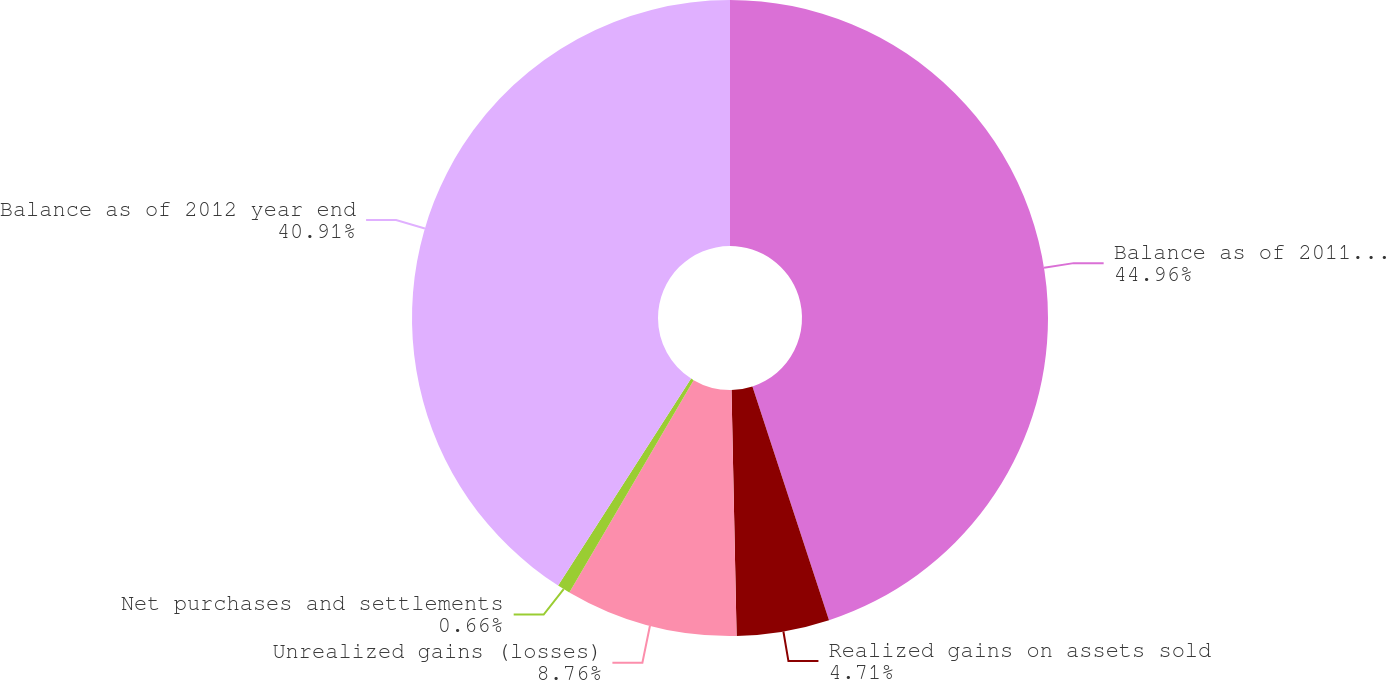Convert chart. <chart><loc_0><loc_0><loc_500><loc_500><pie_chart><fcel>Balance as of 2011 year end<fcel>Realized gains on assets sold<fcel>Unrealized gains (losses)<fcel>Net purchases and settlements<fcel>Balance as of 2012 year end<nl><fcel>44.96%<fcel>4.71%<fcel>8.76%<fcel>0.66%<fcel>40.91%<nl></chart> 